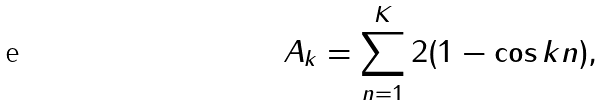<formula> <loc_0><loc_0><loc_500><loc_500>A _ { k } = \sum _ { n = 1 } ^ { K } 2 ( 1 - \cos k n ) ,</formula> 